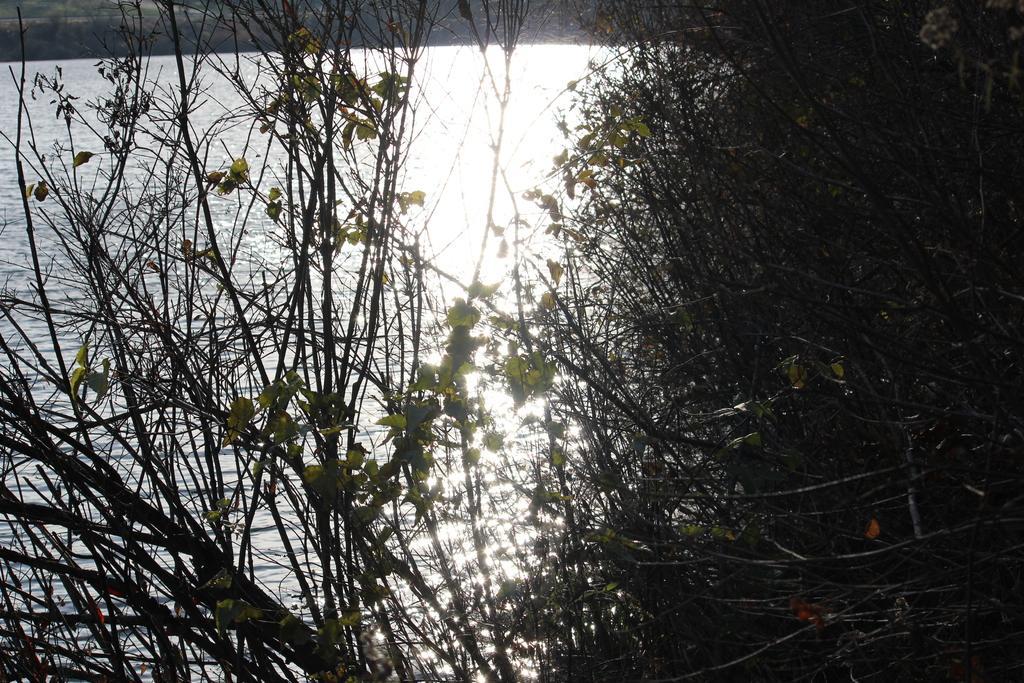In one or two sentences, can you explain what this image depicts? In this image, we can see some plants in front of the lake. 